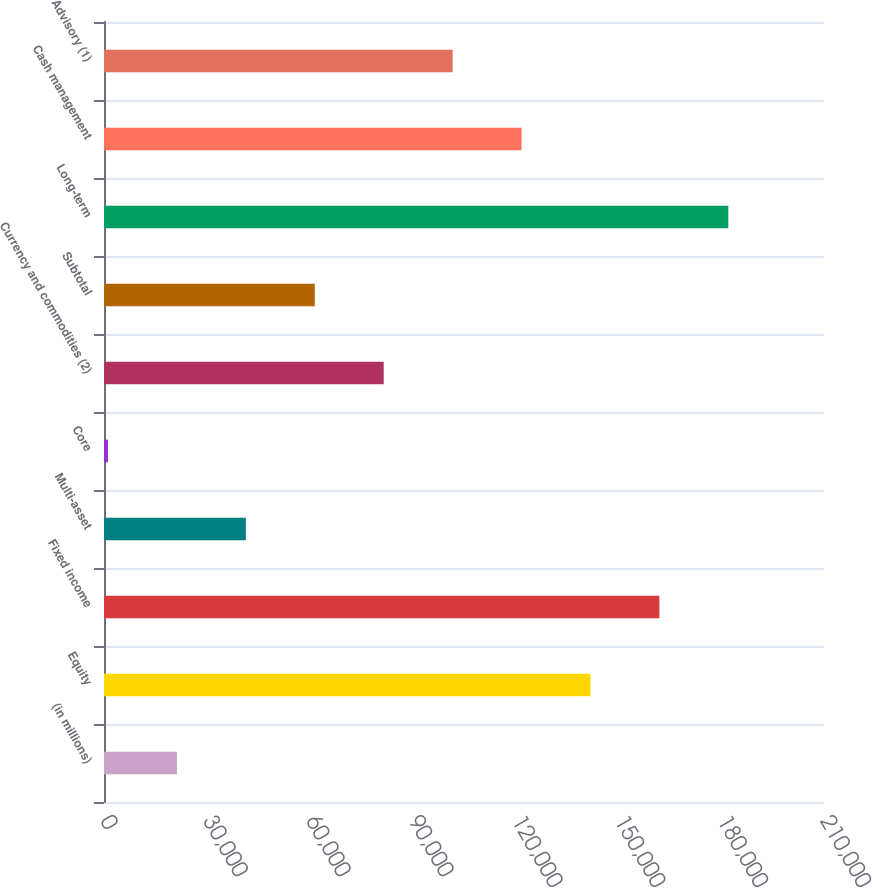Convert chart. <chart><loc_0><loc_0><loc_500><loc_500><bar_chart><fcel>(in millions)<fcel>Equity<fcel>Fixed income<fcel>Multi-asset<fcel>Core<fcel>Currency and commodities (2)<fcel>Subtotal<fcel>Long-term<fcel>Cash management<fcel>Advisory (1)<nl><fcel>21267.6<fcel>141883<fcel>161986<fcel>41370.2<fcel>1165<fcel>81575.4<fcel>61472.8<fcel>182088<fcel>121781<fcel>101678<nl></chart> 